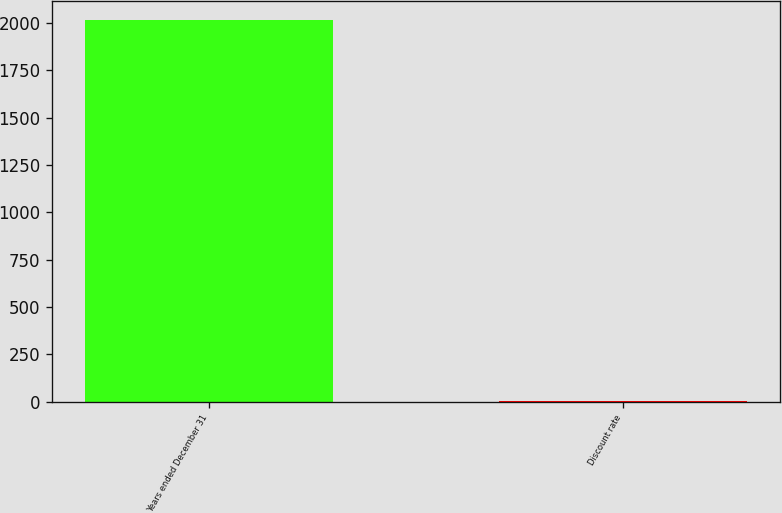Convert chart to OTSL. <chart><loc_0><loc_0><loc_500><loc_500><bar_chart><fcel>Years ended December 31<fcel>Discount rate<nl><fcel>2015<fcel>4.15<nl></chart> 